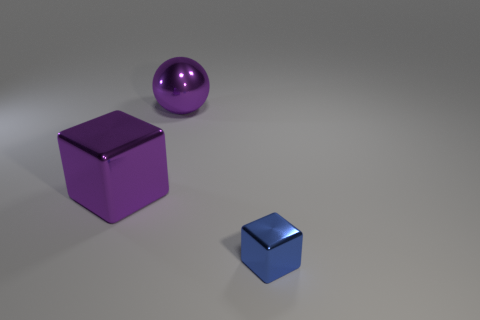Add 1 big brown matte blocks. How many objects exist? 4 Subtract all cubes. How many objects are left? 1 Subtract all purple objects. Subtract all balls. How many objects are left? 0 Add 3 tiny cubes. How many tiny cubes are left? 4 Add 1 purple metal balls. How many purple metal balls exist? 2 Subtract 0 green cylinders. How many objects are left? 3 